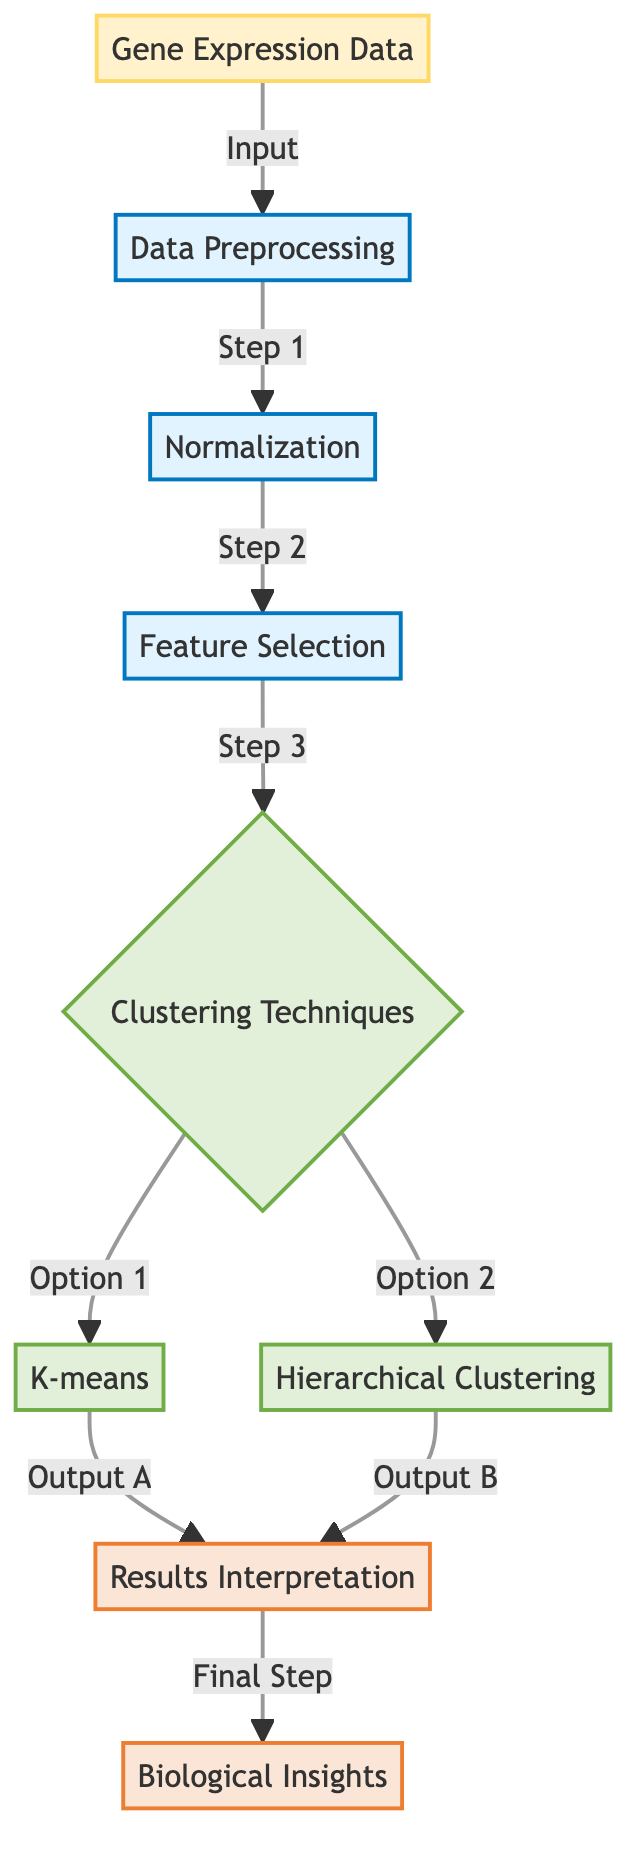what is the first step after inputting gene expression data? The diagram shows that after the input of gene expression data, the first step is data preprocessing. This is indicated by the direct arrow leading from the gene expression data node to the data preprocessing node.
Answer: data preprocessing how many clustering techniques are mentioned in the diagram? The diagram lists two clustering techniques: K-means and hierarchical clustering. These are shown as options under the clustering techniques node, which indicates that there are a total of two techniques being considered.
Answer: two what is the outcome after applying K-means or hierarchical clustering? According to the diagram, the outcome after both K-means and hierarchical clustering is results interpretation. Both paths from K-means and hierarchical clustering lead directly to the results interpretation node.
Answer: results interpretation what comes after feature selection in the process? Following feature selection in the diagram, the next step is clustering techniques. This is shown by an arrow leading from the feature selection node to the clustering techniques node, indicating that clustering techniques are applied after feature selection.
Answer: clustering techniques which component leads to biological insights in the diagram? The component leading to biological insights is the results interpretation. The arrow connecting results interpretation to biological insights signifies that interpreting the results is the final step that yields biological insights.
Answer: results interpretation which node in the diagram outlines the data before preprocessing? The node outlining the data before preprocessing is gene expression data. The diagram displays this at the beginning, indicating that it's the initial data input before any processing occurs.
Answer: gene expression data what is the purpose of normalization in the process? Normalization is part of data preprocessing, as indicated in the diagram, but the diagram does not specify its purpose explicitly. This step typically aims to adjust the data to a common scale.
Answer: (explanation not explicitly stated in the diagram) how many processes are involved before reaching the clustering techniques? There are three processes involved before reaching the clustering techniques: data preprocessing, normalization, and feature selection. Each of these steps leads sequentially to the clustering techniques in the diagram.
Answer: three what is the relationship between results interpretation and biological insights? The relationship is sequential and causal; results interpretation leads to biological insights. In the diagram, there is a directed arrow showing that after interpreting results, the final output is biological insights.
Answer: results interpretation 